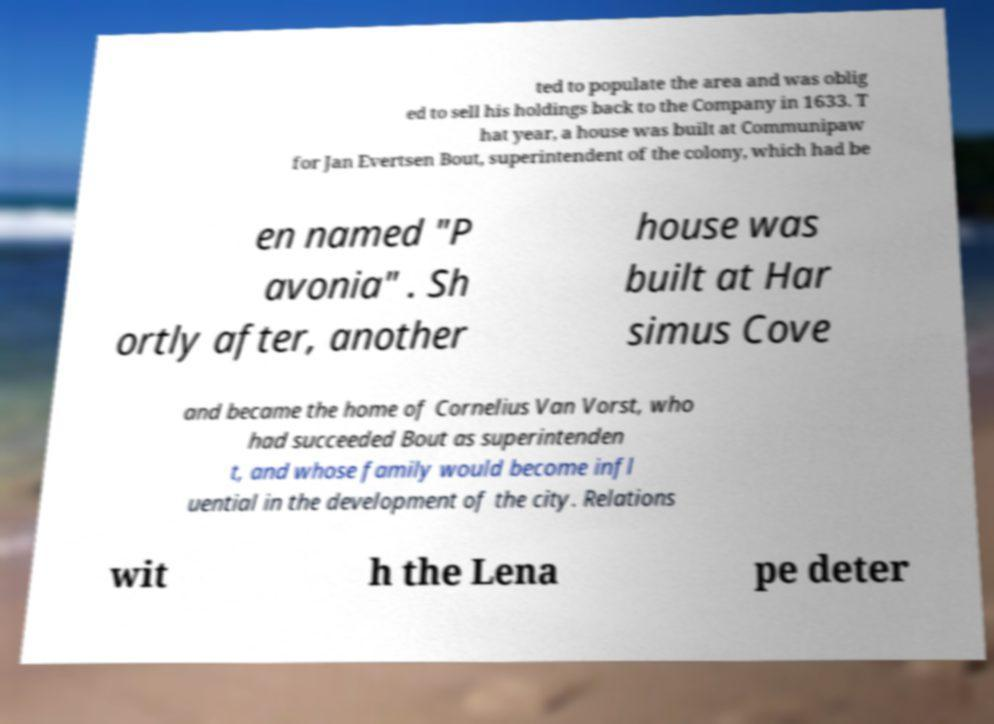Can you read and provide the text displayed in the image?This photo seems to have some interesting text. Can you extract and type it out for me? ted to populate the area and was oblig ed to sell his holdings back to the Company in 1633. T hat year, a house was built at Communipaw for Jan Evertsen Bout, superintendent of the colony, which had be en named "P avonia" . Sh ortly after, another house was built at Har simus Cove and became the home of Cornelius Van Vorst, who had succeeded Bout as superintenden t, and whose family would become infl uential in the development of the city. Relations wit h the Lena pe deter 